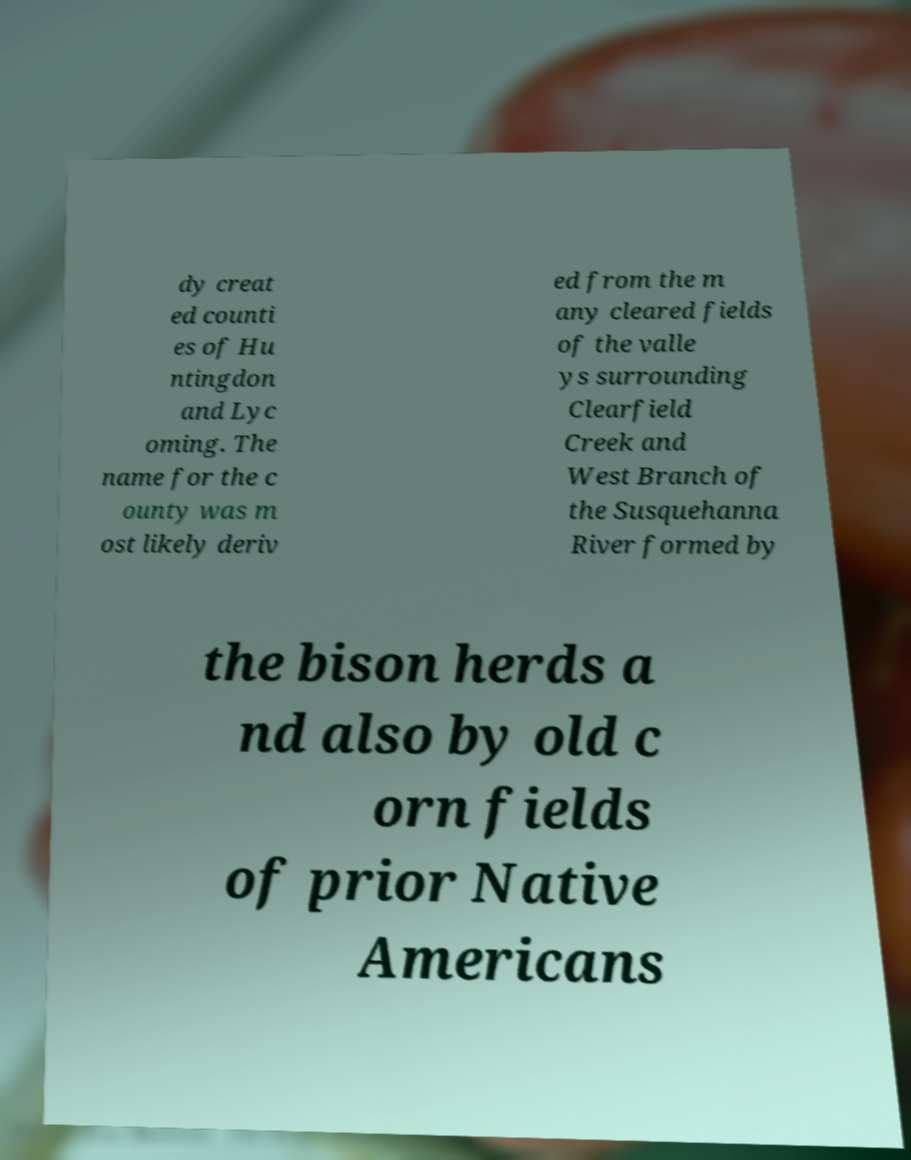What messages or text are displayed in this image? I need them in a readable, typed format. dy creat ed counti es of Hu ntingdon and Lyc oming. The name for the c ounty was m ost likely deriv ed from the m any cleared fields of the valle ys surrounding Clearfield Creek and West Branch of the Susquehanna River formed by the bison herds a nd also by old c orn fields of prior Native Americans 